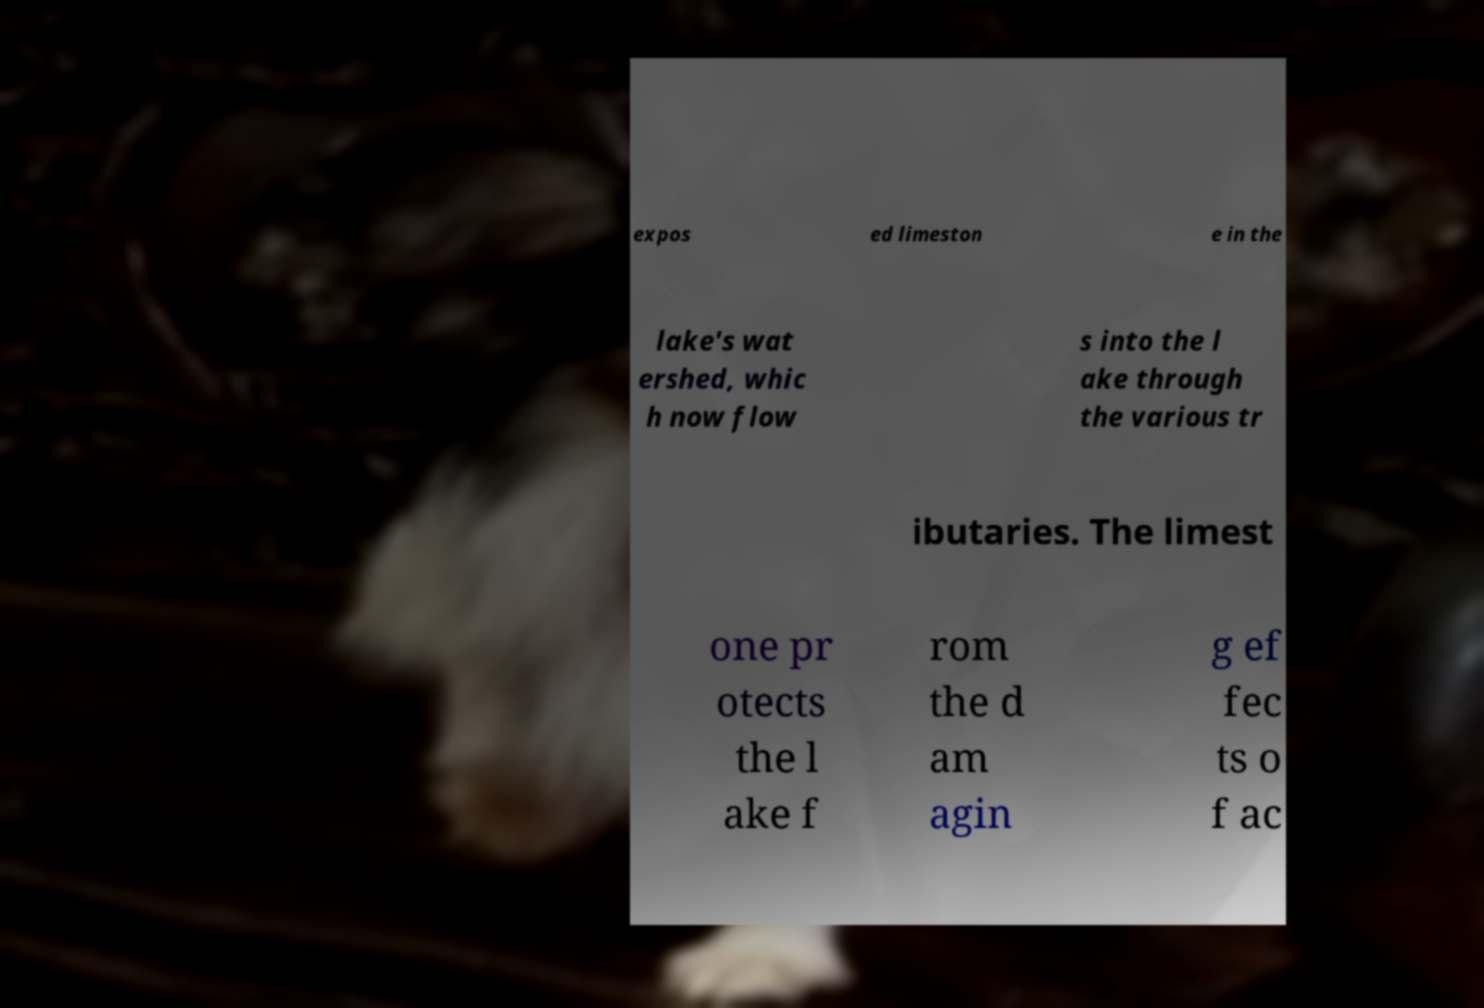Can you read and provide the text displayed in the image?This photo seems to have some interesting text. Can you extract and type it out for me? expos ed limeston e in the lake's wat ershed, whic h now flow s into the l ake through the various tr ibutaries. The limest one pr otects the l ake f rom the d am agin g ef fec ts o f ac 